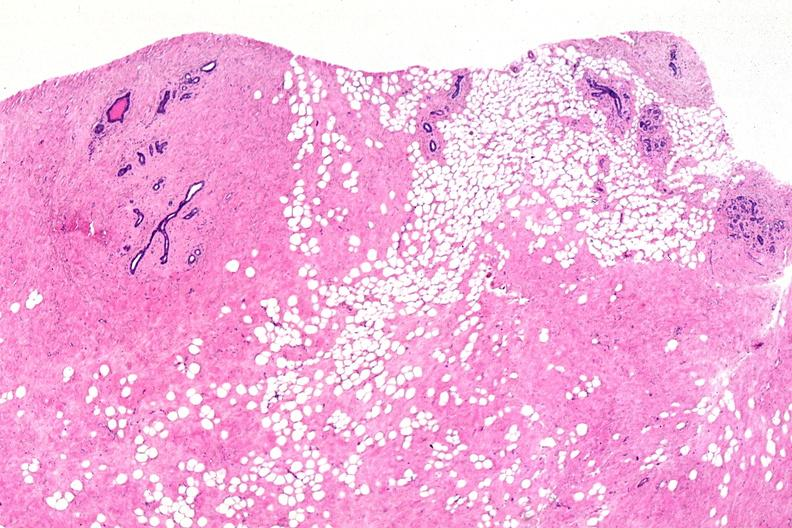what does this image show?
Answer the question using a single word or phrase. Normal breast 